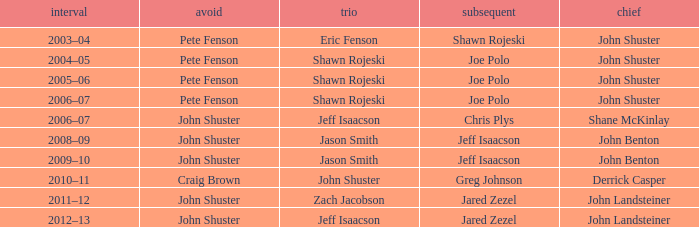Who was the lead with Pete Fenson as skip and Joe Polo as second in season 2005–06? John Shuster. 